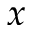Convert formula to latex. <formula><loc_0><loc_0><loc_500><loc_500>x</formula> 